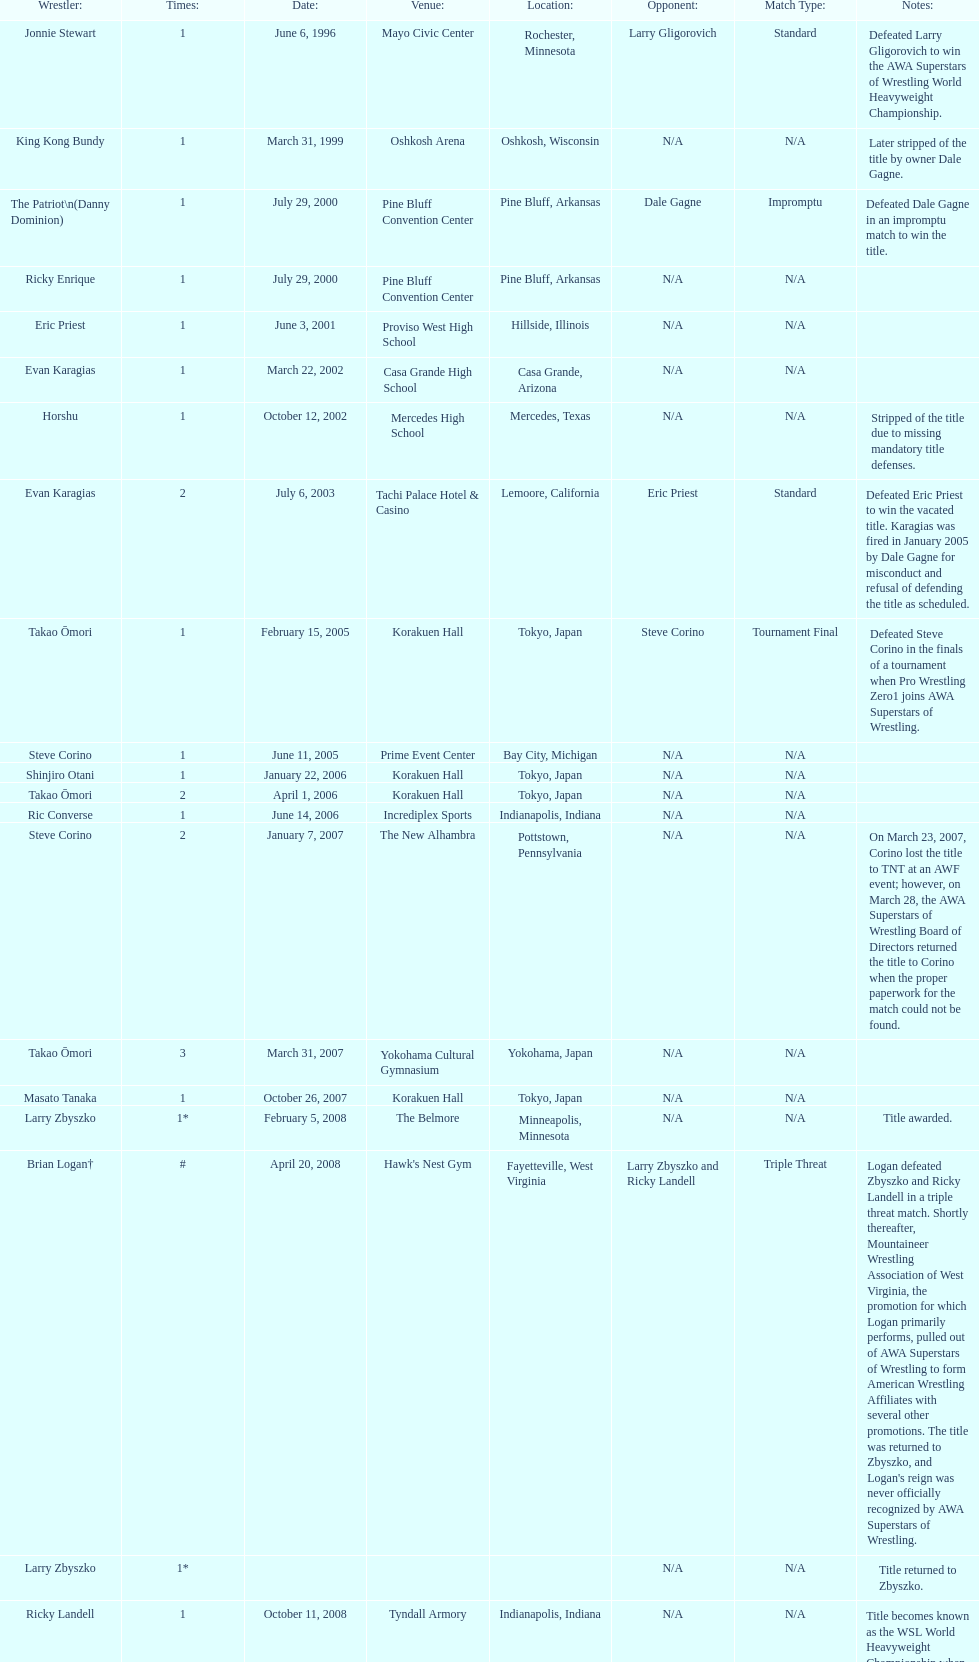Who is listed before keith walker? Ricky Landell. 